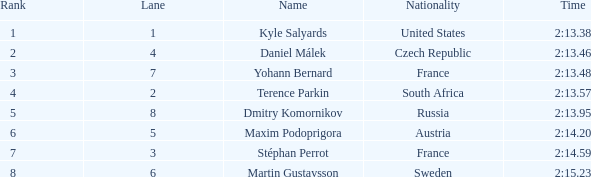What was stéphan perrot's average position? 7.0. 